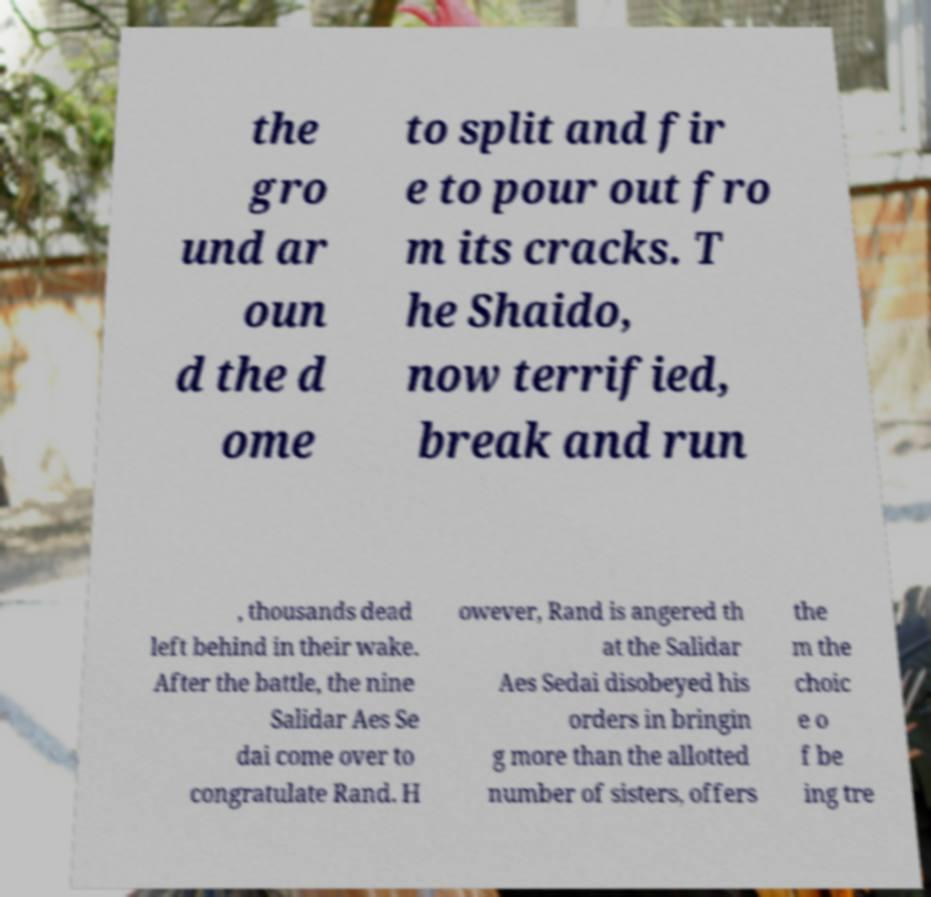Can you accurately transcribe the text from the provided image for me? the gro und ar oun d the d ome to split and fir e to pour out fro m its cracks. T he Shaido, now terrified, break and run , thousands dead left behind in their wake. After the battle, the nine Salidar Aes Se dai come over to congratulate Rand. H owever, Rand is angered th at the Salidar Aes Sedai disobeyed his orders in bringin g more than the allotted number of sisters, offers the m the choic e o f be ing tre 